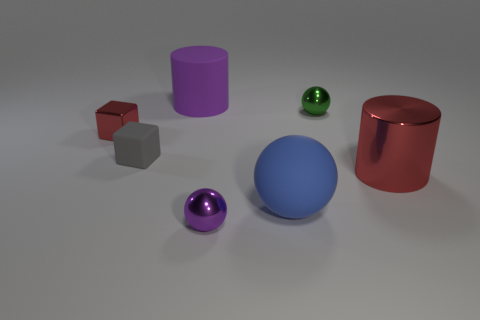How many objects are either shiny objects or small rubber blocks?
Give a very brief answer. 5. There is a shiny cylinder that is the same color as the metallic block; what size is it?
Provide a succinct answer. Large. Are there fewer red cylinders than big rubber things?
Provide a short and direct response. Yes. The red cylinder that is the same material as the tiny purple thing is what size?
Provide a succinct answer. Large. The blue matte object has what size?
Provide a succinct answer. Large. What is the shape of the large blue matte object?
Give a very brief answer. Sphere. Do the large matte thing on the right side of the purple ball and the big metal cylinder have the same color?
Offer a terse response. No. What size is the other metallic thing that is the same shape as the green metal object?
Give a very brief answer. Small. Is there any other thing that has the same material as the big blue object?
Keep it short and to the point. Yes. Are there any purple objects behind the large matte thing behind the big cylinder right of the big rubber cylinder?
Offer a very short reply. No. 